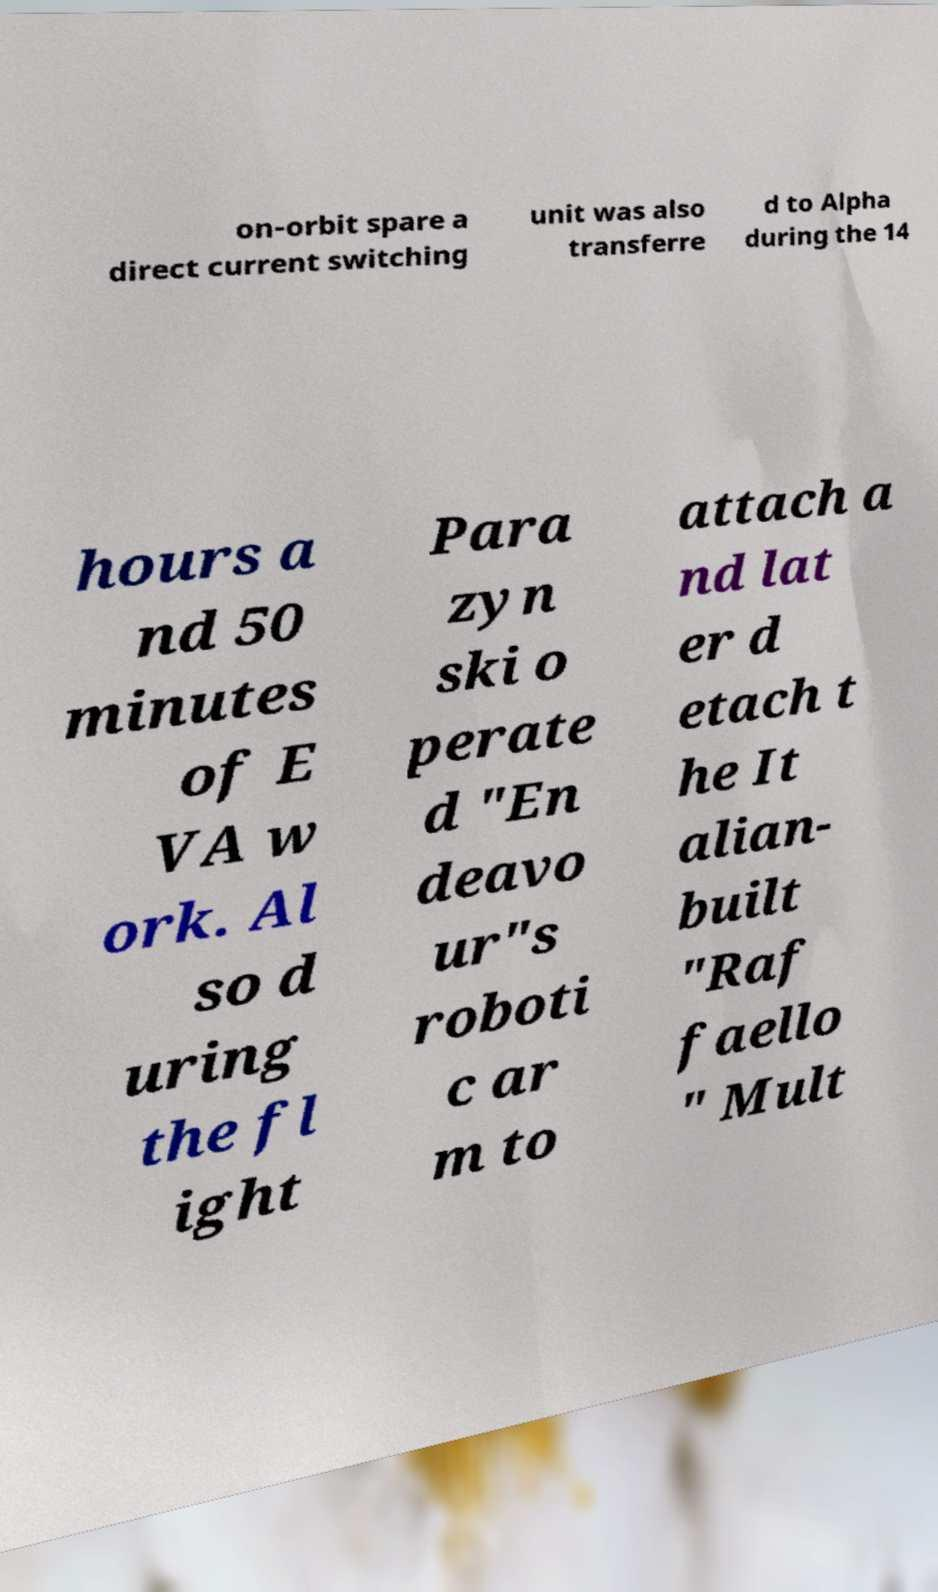What messages or text are displayed in this image? I need them in a readable, typed format. on-orbit spare a direct current switching unit was also transferre d to Alpha during the 14 hours a nd 50 minutes of E VA w ork. Al so d uring the fl ight Para zyn ski o perate d "En deavo ur"s roboti c ar m to attach a nd lat er d etach t he It alian- built "Raf faello " Mult 